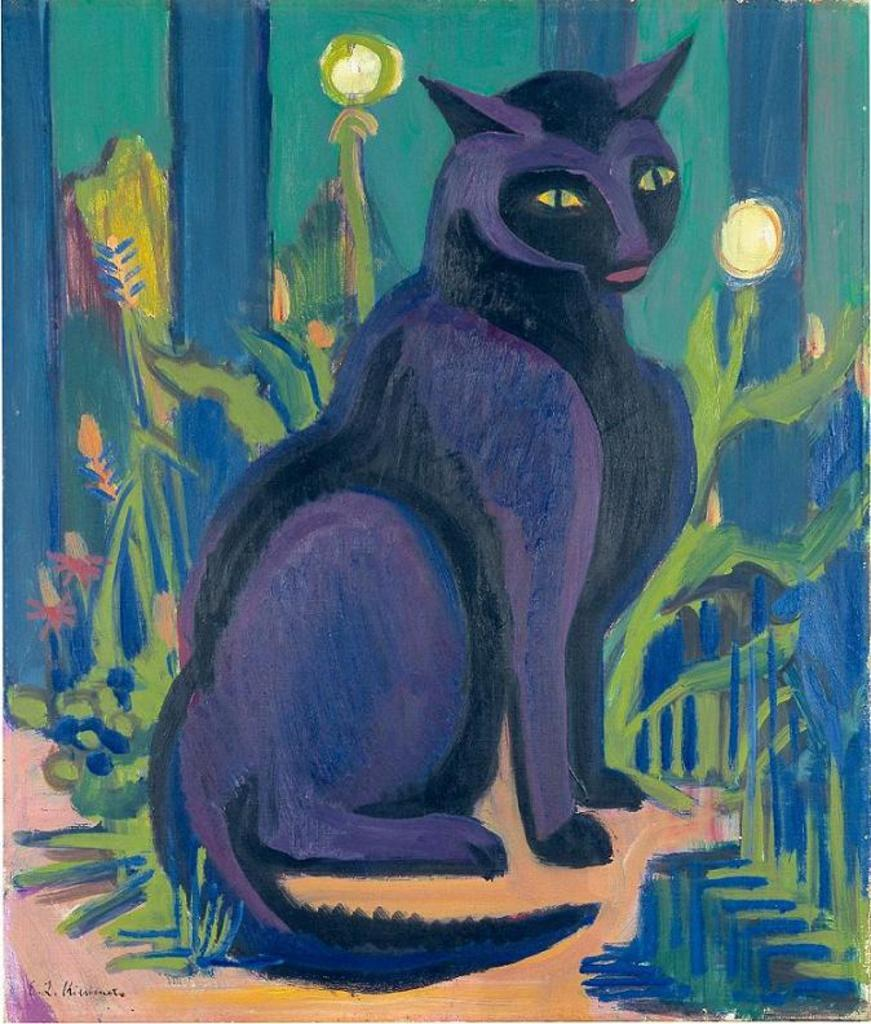What is the main subject of the sketch in the foreground of the picture? There is a sketch of a cat in the foreground of the picture. What can be seen in the background of the sketch? There appears to be a sketch of plants and flowers in the background of the image. What type of berry is being shown in the sketch? There is no berry present in the sketch; it features a cat and plants and flowers. 